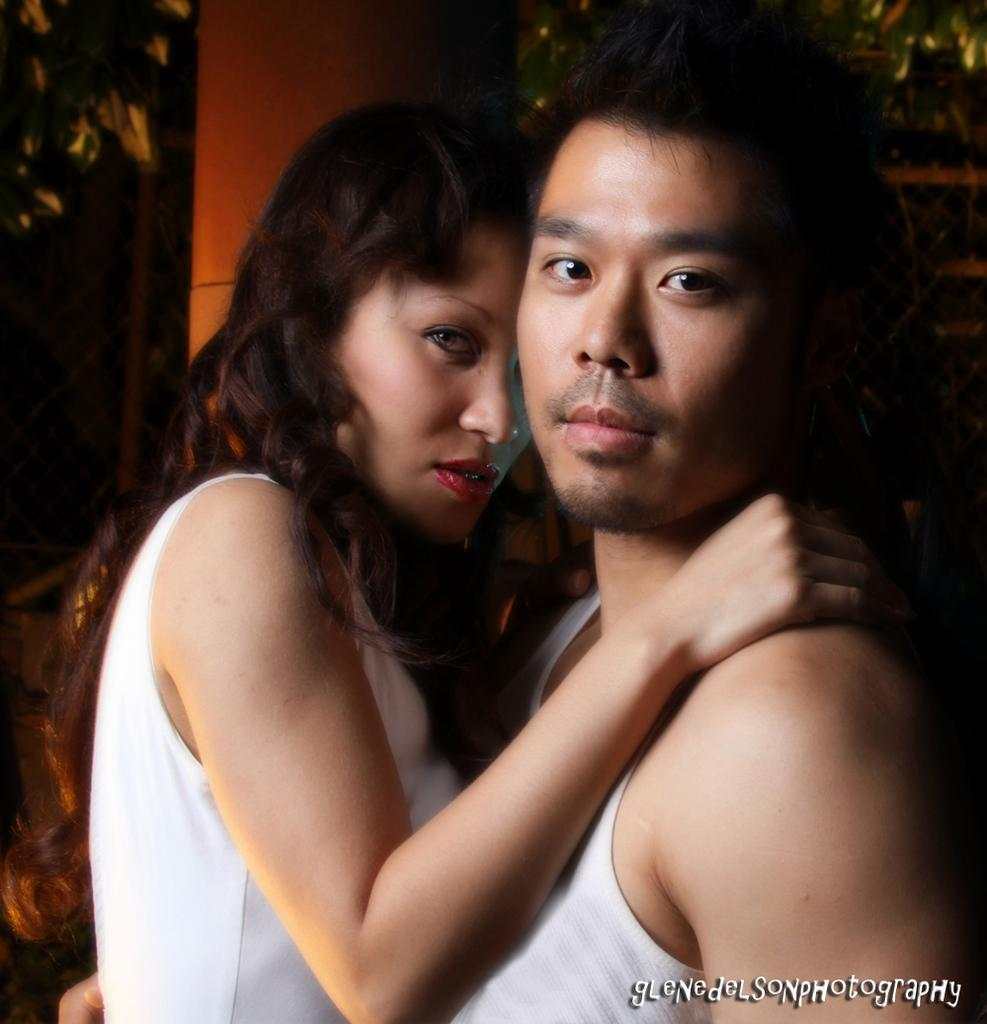What can be seen in the image? There is a couple in the image. What are the individuals in the couple wearing? Both individuals in the couple are wearing white dresses. Is there any additional information about the image? Yes, there is a watermark in the bottom right side of the image. What is the weight of the tramp in the image? There is no tramp present in the image, so it is not possible to determine its weight. 